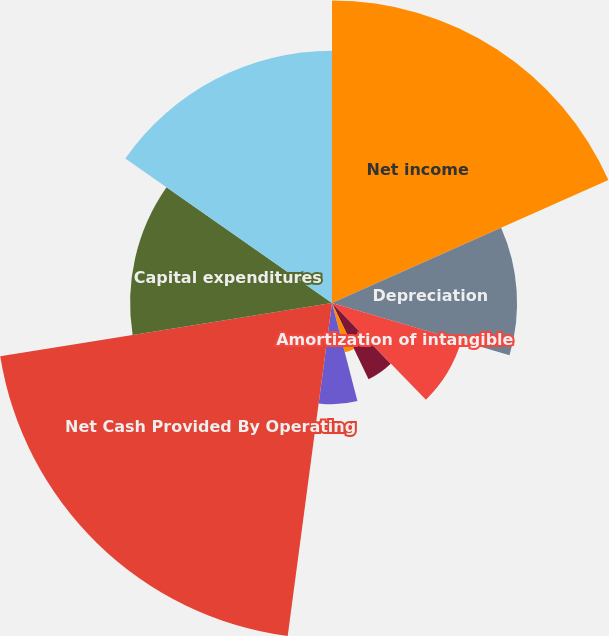Convert chart to OTSL. <chart><loc_0><loc_0><loc_500><loc_500><pie_chart><fcel>Net income<fcel>Depreciation<fcel>Amortization of intangible<fcel>Amortization of deferred gain<fcel>Share-based compensation<fcel>Other net<fcel>Increase in operating capital<fcel>Net Cash Provided By Operating<fcel>Capital expenditures<fcel>Acquisition of businesses and<nl><fcel>18.34%<fcel>11.22%<fcel>8.17%<fcel>0.03%<fcel>5.12%<fcel>3.09%<fcel>6.14%<fcel>20.37%<fcel>12.24%<fcel>15.29%<nl></chart> 